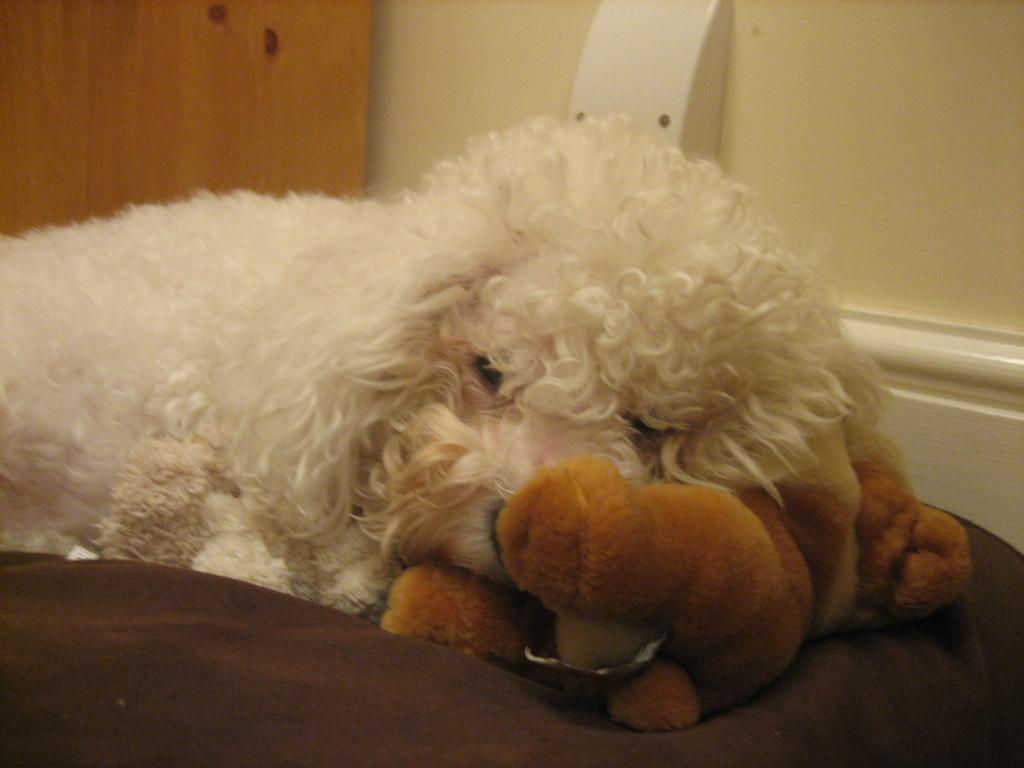Please provide a concise description of this image. This image consists of a dog. In the front, we can see a doll. At the bottom, it looks like a dog bed. In the background, there is a door and a wall. 